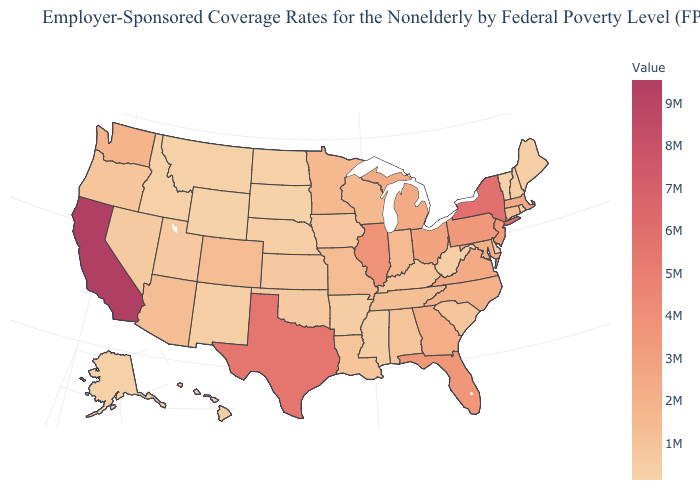Does Iowa have the lowest value in the USA?
Concise answer only. No. Does Minnesota have the lowest value in the MidWest?
Short answer required. No. Which states have the lowest value in the South?
Give a very brief answer. Delaware. Which states have the highest value in the USA?
Answer briefly. California. Among the states that border Louisiana , which have the highest value?
Answer briefly. Texas. Which states have the highest value in the USA?
Give a very brief answer. California. Does Rhode Island have the highest value in the Northeast?
Write a very short answer. No. Among the states that border Missouri , which have the lowest value?
Write a very short answer. Nebraska. Which states have the lowest value in the West?
Be succinct. Wyoming. 